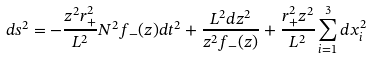<formula> <loc_0><loc_0><loc_500><loc_500>d s ^ { 2 } = - \frac { z ^ { 2 } r _ { + } ^ { 2 } } { L ^ { 2 } } N ^ { 2 } f _ { - } ( z ) d t ^ { 2 } + \frac { L ^ { 2 } d z ^ { 2 } } { z ^ { 2 } f _ { - } ( z ) } + \frac { r _ { + } ^ { 2 } z ^ { 2 } } { L ^ { 2 } } \sum _ { i = 1 } ^ { 3 } d x _ { i } ^ { 2 }</formula> 